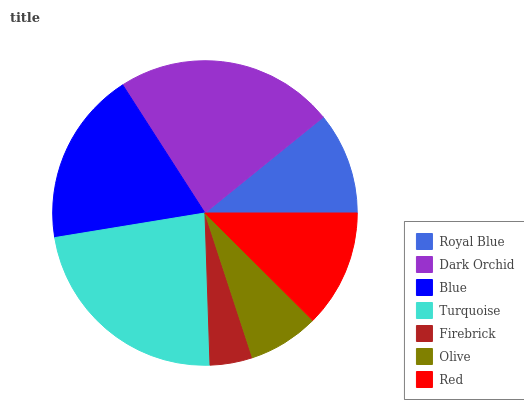Is Firebrick the minimum?
Answer yes or no. Yes. Is Dark Orchid the maximum?
Answer yes or no. Yes. Is Blue the minimum?
Answer yes or no. No. Is Blue the maximum?
Answer yes or no. No. Is Dark Orchid greater than Blue?
Answer yes or no. Yes. Is Blue less than Dark Orchid?
Answer yes or no. Yes. Is Blue greater than Dark Orchid?
Answer yes or no. No. Is Dark Orchid less than Blue?
Answer yes or no. No. Is Red the high median?
Answer yes or no. Yes. Is Red the low median?
Answer yes or no. Yes. Is Blue the high median?
Answer yes or no. No. Is Olive the low median?
Answer yes or no. No. 